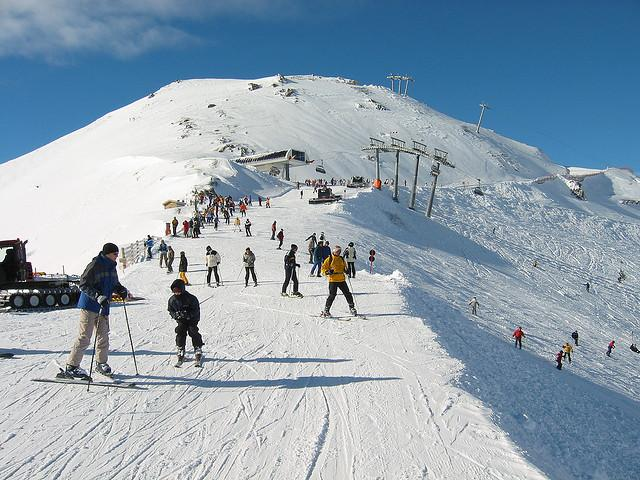What sort of skill is required at the slope in the foreground here?

Choices:
A) olympic
B) professional
C) beginner
D) hot dog beginner 